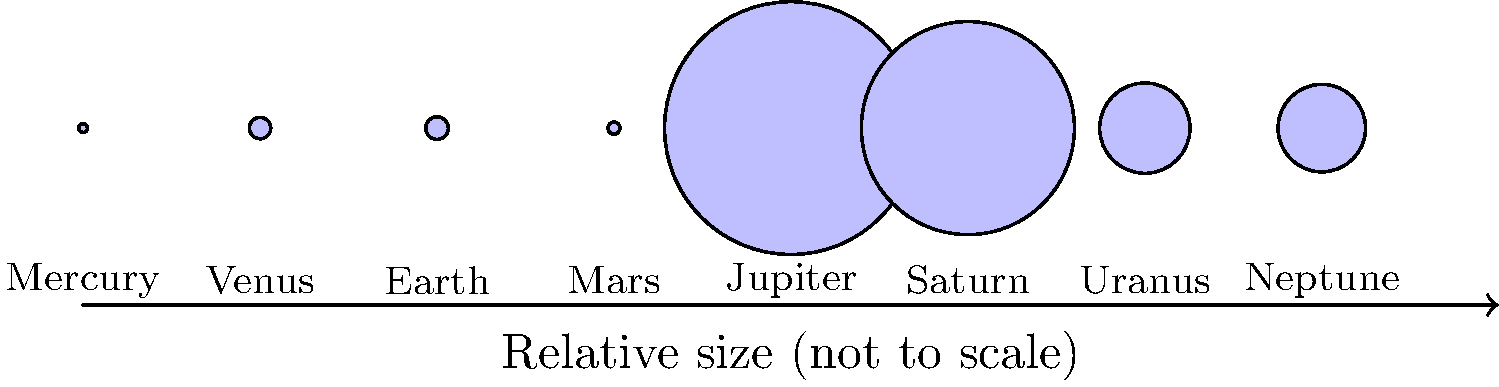As an interior designer specializing in baby rooms, you're creating a space-themed nursery. You want to paint a mural of the solar system on one wall, accurately representing the relative sizes of the planets. Based on the diagram, which planet should be painted as the largest, and how many times larger should it be compared to Earth? To answer this question, we need to follow these steps:

1. Identify the largest planet in the diagram:
   By observing the circles, we can see that Jupiter is the largest planet.

2. Find the size of Jupiter:
   From the given data, Jupiter's size is 142,984 km in diameter.

3. Find the size of Earth:
   Earth's size is given as 12,756 km in diameter.

4. Calculate the ratio of Jupiter's size to Earth's size:
   $\frac{\text{Jupiter's size}}{\text{Earth's size}} = \frac{142,984}{12,756} \approx 11.21$

5. Round the result to the nearest whole number:
   11.21 rounded to the nearest whole number is 11.

Therefore, in the mural, Jupiter should be painted as the largest planet, and it should be approximately 11 times larger than Earth.
Answer: Jupiter, 11 times larger than Earth 